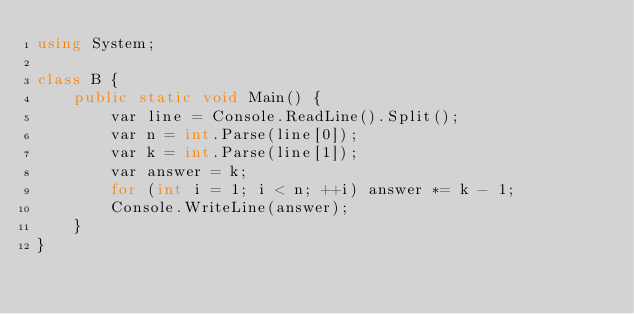<code> <loc_0><loc_0><loc_500><loc_500><_C#_>using System;

class B {
    public static void Main() {
        var line = Console.ReadLine().Split();
        var n = int.Parse(line[0]);
        var k = int.Parse(line[1]);
        var answer = k;
        for (int i = 1; i < n; ++i) answer *= k - 1;
        Console.WriteLine(answer);
    }
}
</code> 